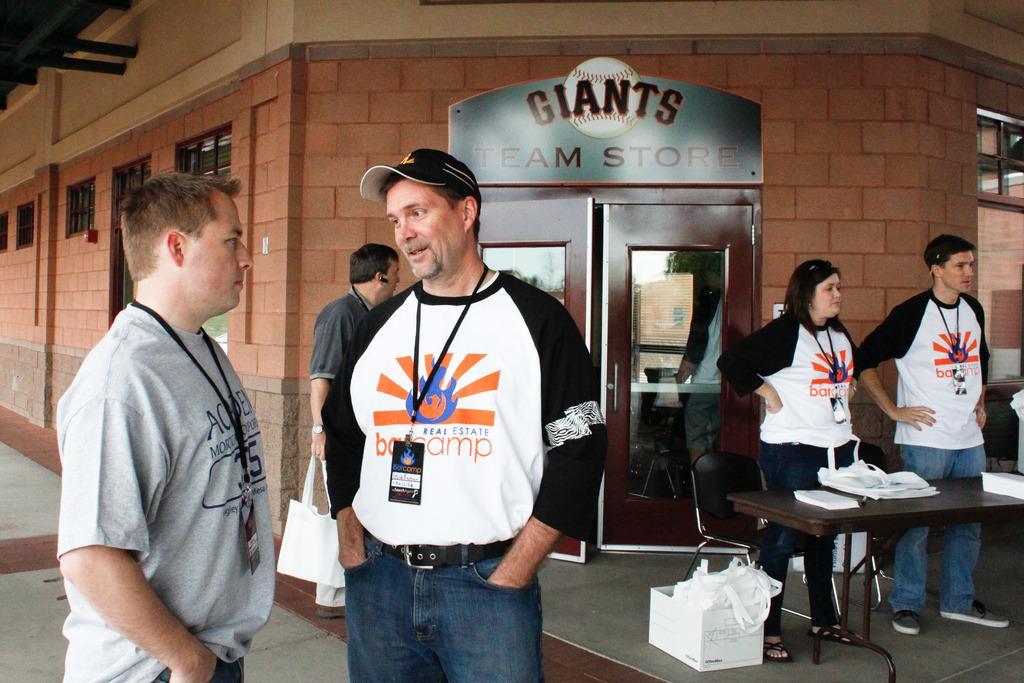Can you describe this image briefly? In this image, we can see people standing and wearing id cards and one of them is wearing a cap and we can see bags and some other objects on the table. At the bottom, there is a box and we can see some bags, on the the floor. In the background, there is a building and we can see a door and windows. 